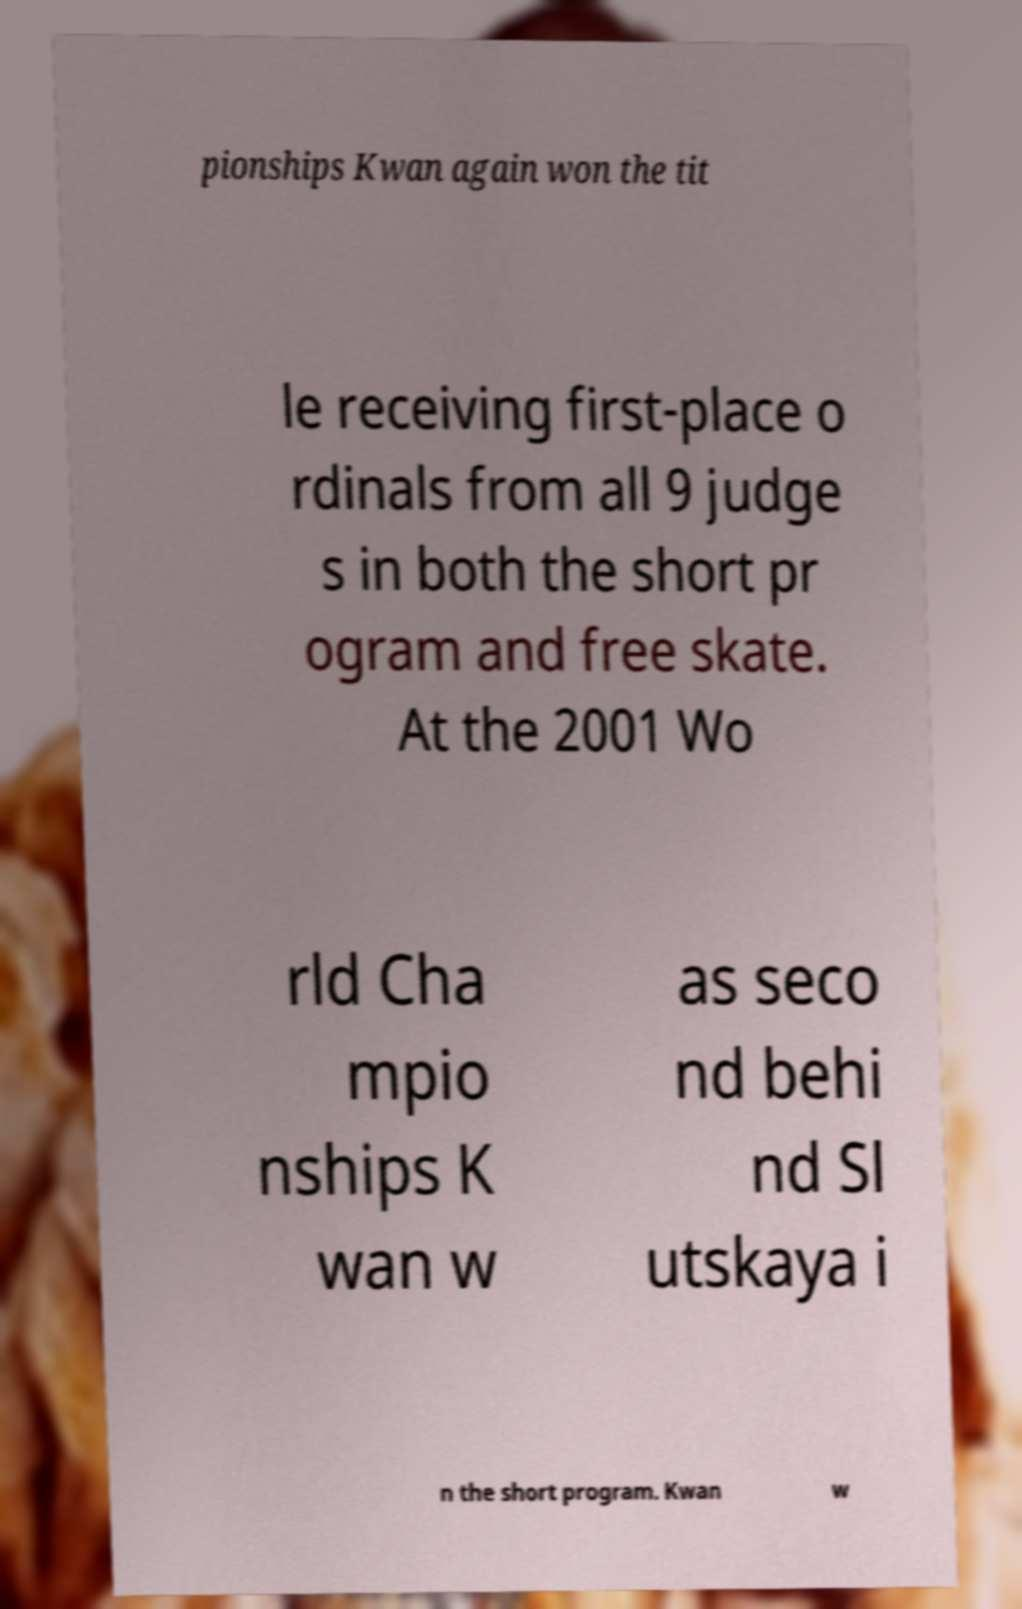There's text embedded in this image that I need extracted. Can you transcribe it verbatim? pionships Kwan again won the tit le receiving first-place o rdinals from all 9 judge s in both the short pr ogram and free skate. At the 2001 Wo rld Cha mpio nships K wan w as seco nd behi nd Sl utskaya i n the short program. Kwan w 